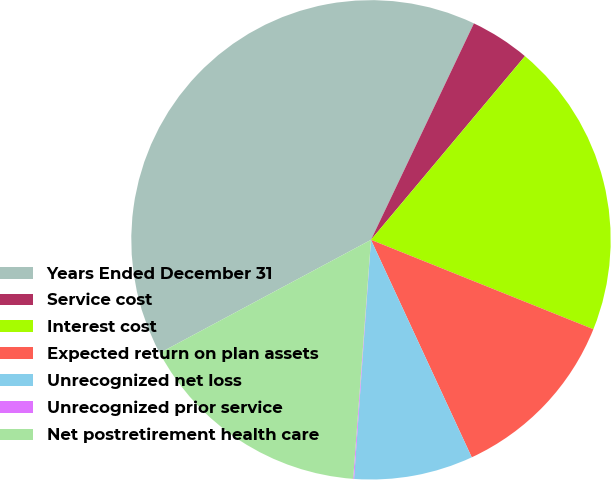Convert chart to OTSL. <chart><loc_0><loc_0><loc_500><loc_500><pie_chart><fcel>Years Ended December 31<fcel>Service cost<fcel>Interest cost<fcel>Expected return on plan assets<fcel>Unrecognized net loss<fcel>Unrecognized prior service<fcel>Net postretirement health care<nl><fcel>39.89%<fcel>4.04%<fcel>19.98%<fcel>12.01%<fcel>8.03%<fcel>0.06%<fcel>15.99%<nl></chart> 